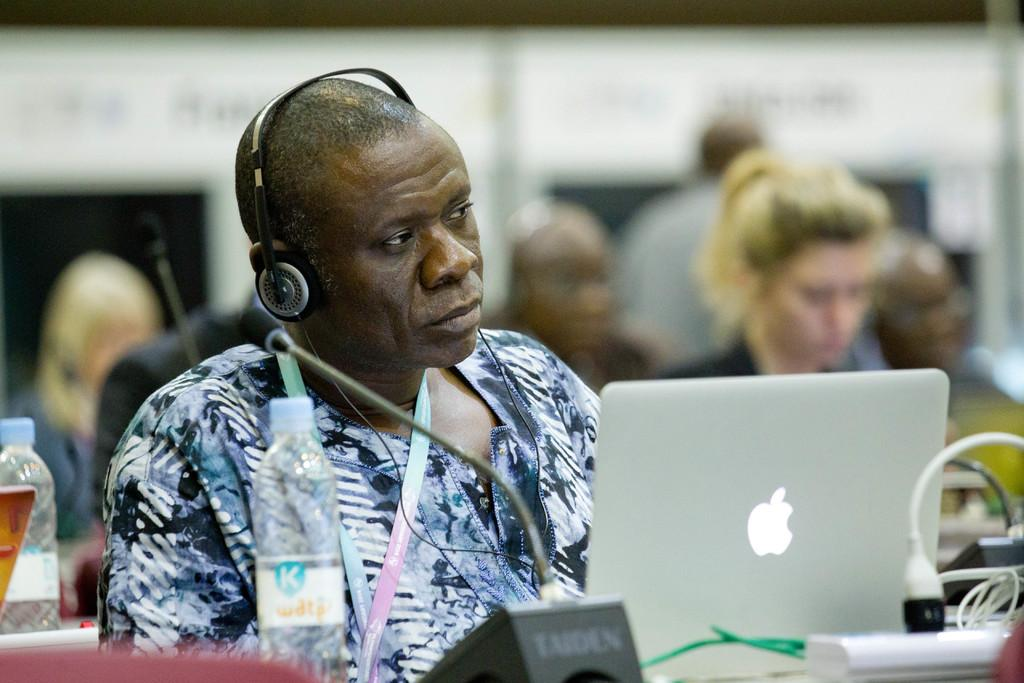What are the people in the image doing? The people in the image are sitting on chairs. What objects are in front of the chairs? Desks are present in front of the chairs. What can be seen on the desks? There is a microphone, disposal bottles, laptops, cables, and an extension board on the desks. What type of pollution is visible in the image? There is no visible pollution in the image. How do the people in the image grip the microphone? The image does not show how the people are gripping the microphone, as it only shows the presence of a microphone on the desks. 